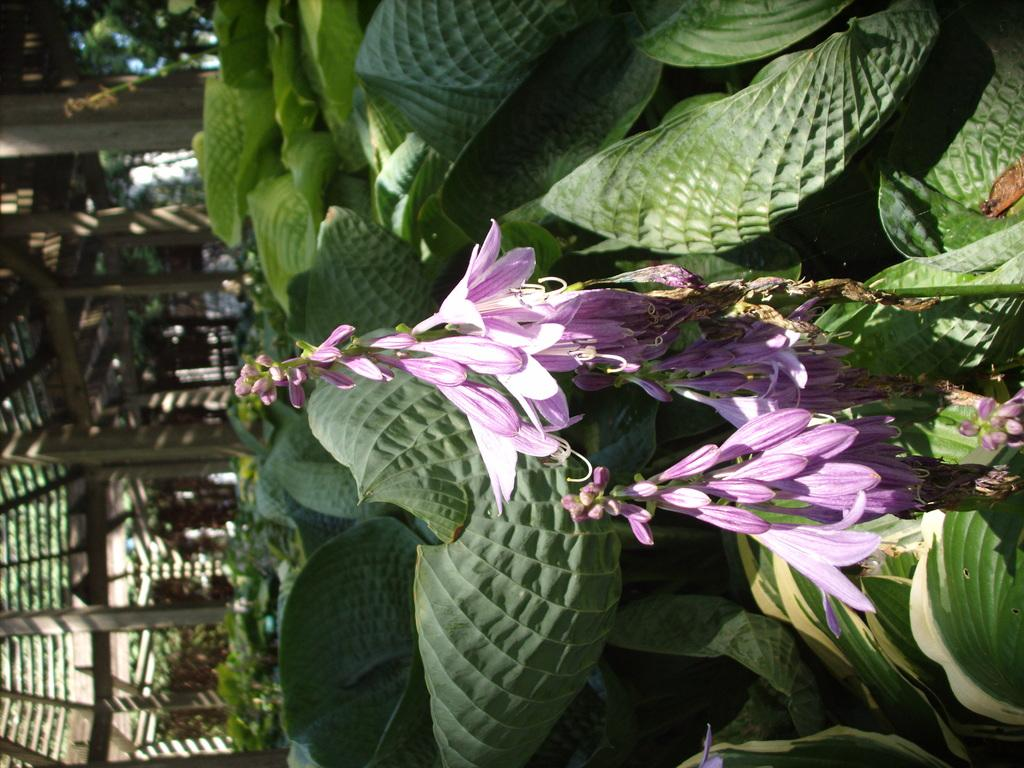What type of plants can be seen in the image? There are flowers and leaves in the image. What architectural feature is present in the image? There are pillars in the image. Can you describe any other objects in the image? There are some other objects in the image, but their specific details are not mentioned in the provided facts. Where is the baby playing with the goose on the slope in the image? There is no baby, goose, or slope present in the image. 